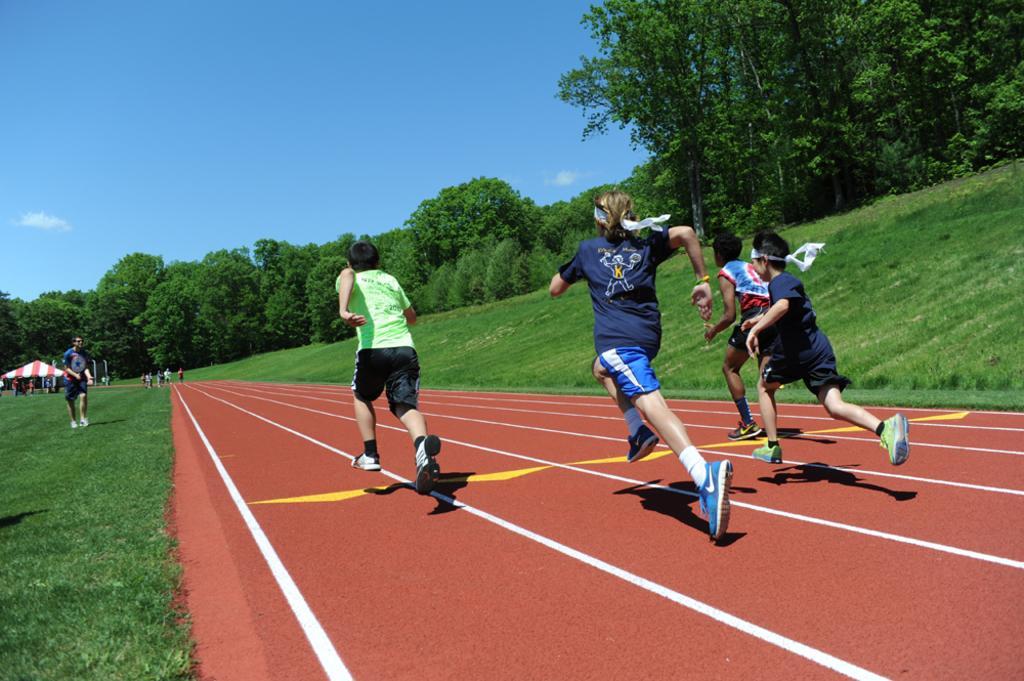Please provide a concise description of this image. In this image we can see a few people, among them some are running and some are standing on the ground, there are some trees, poles, grass and a tent, in the background we can see the sky. 